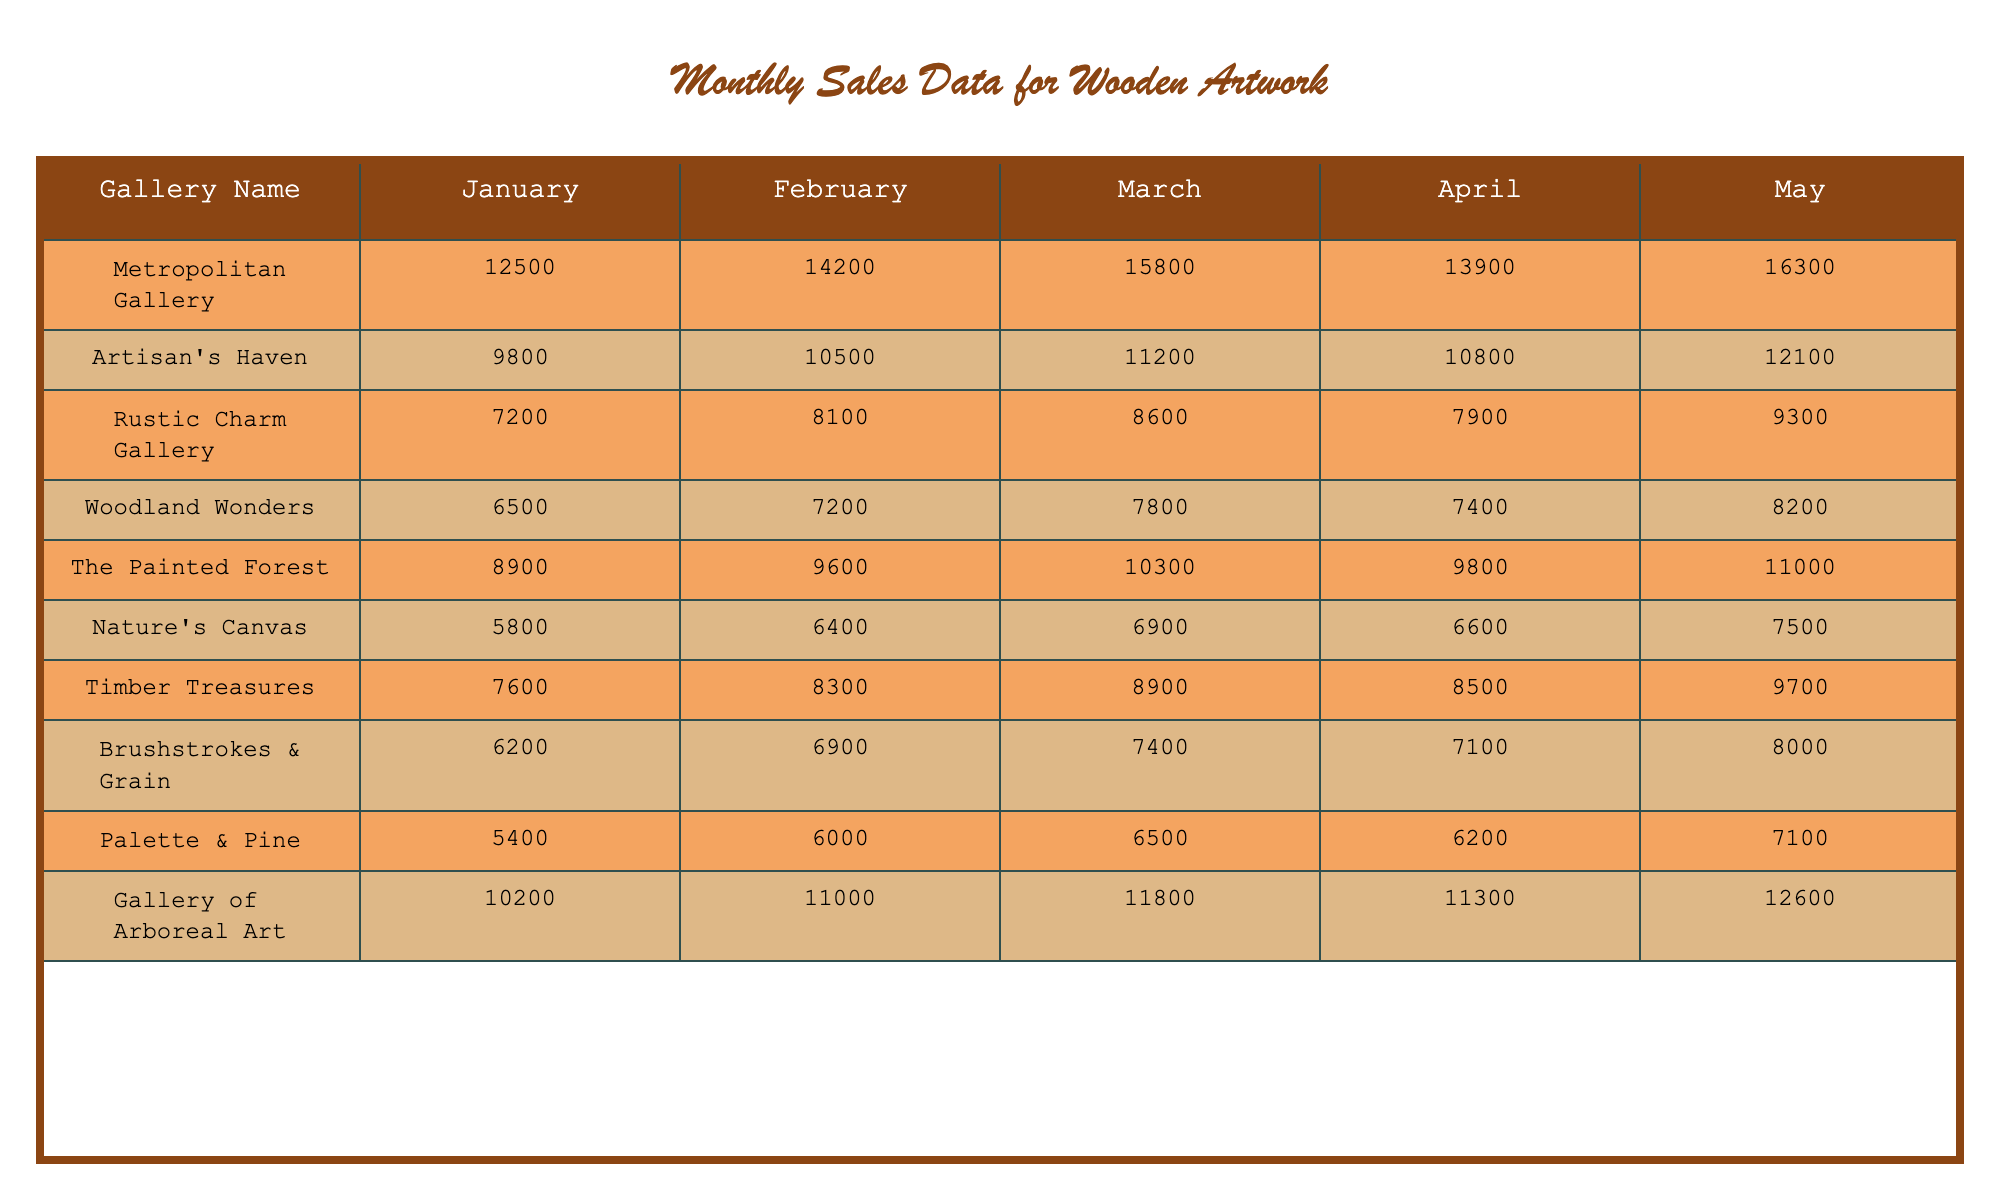What was the total sales for the Metropolitan Gallery in May? From the table, the sales amount for the Metropolitan Gallery in May is 16,300.
Answer: 16300 Which gallery had the highest sales in March? Looking at the data for March, the Metropolitan Gallery recorded sales of 15,800, which is the highest among all galleries.
Answer: Metropolitan Gallery What are the sales figures for Artisan's Haven in the first quarter (January to March)? The sales figures for Artisan's Haven are 9,800 for January, 10,500 for February, and 11,200 for March. We can sum these values: 9,800 + 10,500 + 11,200 = 31,500.
Answer: 31500 Is the Woodland Wonders gallery's sales in February more than 7,500? From the table, Woodland Wonders had sales of 7,200 in February, which is less than 7,500.
Answer: No What is the average sales for Nature's Canvas over the five months? The sales for Nature's Canvas are: 5,800 (January), 6,400 (February), 6,900 (March), 6,600 (April), and 7,500 (May). To find the average, we sum these values: 5,800 + 6,400 + 6,900 + 6,600 + 7,500 = 33,200 and divide by 5, which results in 33,200 / 5 = 6,640.
Answer: 6640 What was the overall sales trend for Rustic Charm Gallery from January to May? By comparing the figures, Rustic Charm Gallery’s sales were 7,200 (January), 8,100 (February), 8,600 (March), 7,900 (April), and 9,300 (May). The trend shows a general increase with slight fluctuation— an increase from January to March, a drop in April, and a rise in May.
Answer: Generally increasing Which gallery had the lowest sales in April? For April, the sales figures are: Metropolitan Gallery 13,900, Artisan's Haven 10,800, Rustic Charm Gallery 7,900, Woodland Wonders 7,400, The Painted Forest 9,800, Nature's Canvas 6,600, Timber Treasures 8,500, Brushstrokes & Grain 7,100, Palette & Pine 6,200, and Gallery of Arboreal Art 11,300. The lowest sales belong to Palette & Pine at 6,200.
Answer: Palette & Pine What would be the percentage increase in sales for Gallery of Arboreal Art from January to May? The sales for Gallery of Arboreal Art in January are 10,200 and in May are 12,600. To find the percentage increase: ((12,600 - 10,200) / 10,200) * 100 = (2,400 / 10,200) * 100 = 23.53%.
Answer: 23.53% Which gallery consistently had sales above 7,000 in all five months? By analyzing the sales figures, Artisan's Haven, Timber Treasures, and Gallery of Arboreal Art are the galleries that consistently had sales above 7,000 in every month.
Answer: Artisan's Haven, Timber Treasures, Gallery of Arboreal Art In which month did Brushstrokes & Grain achieve its highest sales? The sales for Brushstrokes & Grain were: 6,200 (January), 6,900 (February), 7,400 (March), 7,100 (April), and 8,000 (May). The highest sales occurred in May at 8,000.
Answer: May 